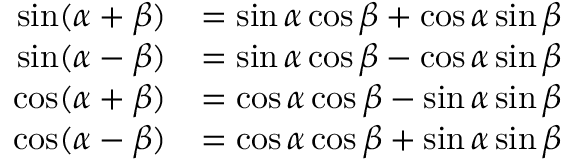Convert formula to latex. <formula><loc_0><loc_0><loc_500><loc_500>{ \begin{array} { r l } { \sin ( \alpha + \beta ) } & { = \sin \alpha \cos \beta + \cos \alpha \sin \beta } \\ { \sin ( \alpha - \beta ) } & { = \sin \alpha \cos \beta - \cos \alpha \sin \beta } \\ { \cos ( \alpha + \beta ) } & { = \cos \alpha \cos \beta - \sin \alpha \sin \beta } \\ { \cos ( \alpha - \beta ) } & { = \cos \alpha \cos \beta + \sin \alpha \sin \beta } \end{array} }</formula> 